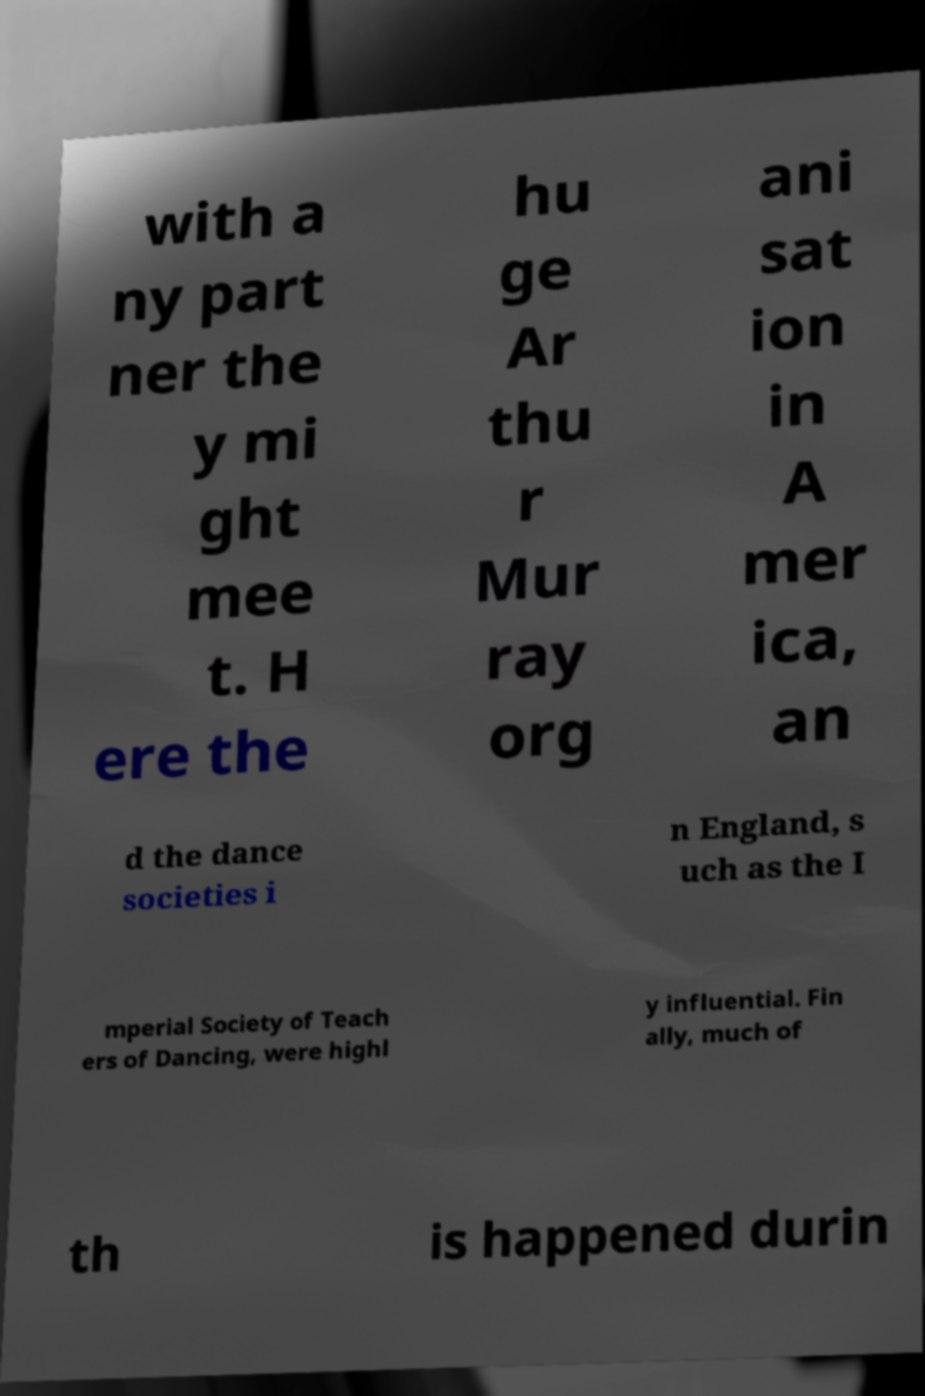Could you assist in decoding the text presented in this image and type it out clearly? with a ny part ner the y mi ght mee t. H ere the hu ge Ar thu r Mur ray org ani sat ion in A mer ica, an d the dance societies i n England, s uch as the I mperial Society of Teach ers of Dancing, were highl y influential. Fin ally, much of th is happened durin 